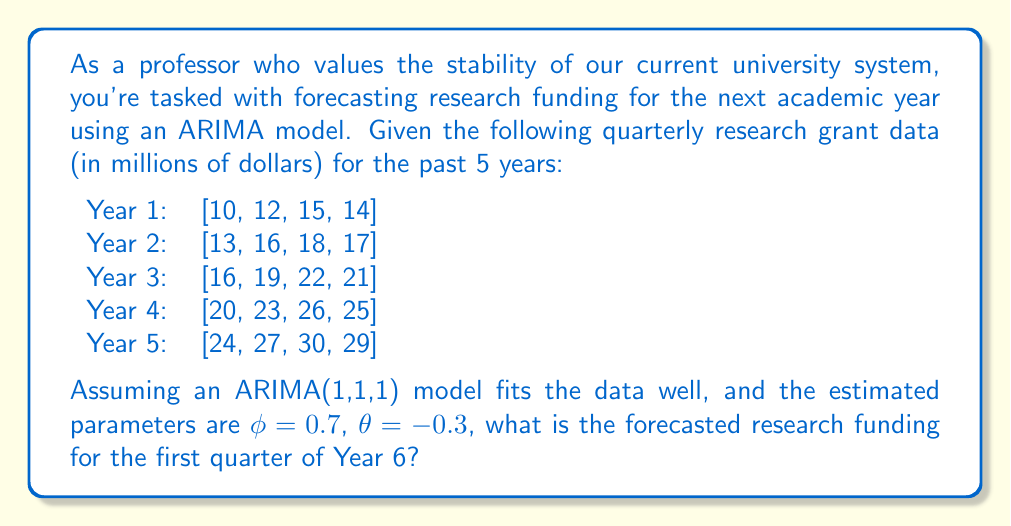Could you help me with this problem? To forecast the research funding using an ARIMA(1,1,1) model, we'll follow these steps:

1) First, we need to understand the ARIMA(1,1,1) model:
   - It has one autoregressive term (p=1)
   - It uses first-order differencing (d=1)
   - It has one moving average term (q=1)

2) The general form of an ARIMA(1,1,1) model is:

   $$(1-\phi B)(1-B)y_t = (1+\theta B)\epsilon_t$$

   where $B$ is the backshift operator, $\phi$ is the autoregressive parameter, $\theta$ is the moving average parameter, and $\epsilon_t$ is white noise.

3) For forecasting, we use the following equation:

   $$\hat{y}_{t+1} = y_t + \phi(y_t - y_{t-1}) - \theta\epsilon_t$$

4) We're given $\phi = 0.7$ and $\theta = -0.3$. We need to find $y_t$, $y_{t-1}$, and $\epsilon_t$.

5) $y_t$ is the last observed value: 29 (Q4 of Year 5)
   $y_{t-1}$ is the second-to-last observed value: 30 (Q3 of Year 5)

6) To estimate $\epsilon_t$, we need to calculate the forecast error for the last period:
   $\epsilon_t = y_t - \hat{y}_t$

   We can approximate $\hat{y}_t$ using the same formula:
   $\hat{y}_t = y_{t-1} + \phi(y_{t-1} - y_{t-2}) - \theta\epsilon_{t-1}$

   $\hat{y}_t = 30 + 0.7(30 - 27) - (-0.3)\epsilon_{t-1}$
   
   Assuming $\epsilon_{t-1} \approx 0$ for simplicity:
   $\hat{y}_t = 30 + 0.7(3) = 32.1$

   Therefore, $\epsilon_t = 29 - 32.1 = -3.1$

7) Now we can forecast $\hat{y}_{t+1}$:

   $\hat{y}_{t+1} = 29 + 0.7(29 - 30) - (-0.3)(-3.1)$
                 $= 29 - 0.7 + 0.93$
                 $= 29.23$

Thus, the forecasted research funding for the first quarter of Year 6 is approximately $29.23 million.
Answer: $29.23 million 